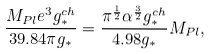Convert formula to latex. <formula><loc_0><loc_0><loc_500><loc_500>\frac { M _ { P l } e ^ { 3 } g ^ { c h } _ { * } } { 3 9 . 8 4 \pi g _ { * } } = \frac { \pi ^ { \frac { 1 } { 2 } } \alpha ^ { \frac { 3 } { 2 } } g ^ { c h } _ { * } } { 4 . 9 8 g _ { * } } M _ { P l } ,</formula> 